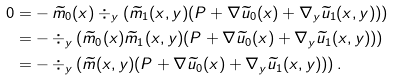Convert formula to latex. <formula><loc_0><loc_0><loc_500><loc_500>0 = & - \widetilde { m } _ { 0 } ( x ) \div _ { y } \left ( \widetilde { m } _ { 1 } ( x , y ) ( P + \nabla \widetilde { u } _ { 0 } ( x ) + \nabla _ { y } \widetilde { u } _ { 1 } ( x , y ) ) \right ) \\ = & - \div _ { y } \left ( \widetilde { m } _ { 0 } ( x ) \widetilde { m } _ { 1 } ( x , y ) ( P + \nabla \widetilde { u } _ { 0 } ( x ) + \nabla _ { y } \widetilde { u } _ { 1 } ( x , y ) ) \right ) \\ = & - \div _ { y } \left ( \widetilde { m } ( x , y ) ( P + \nabla \widetilde { u } _ { 0 } ( x ) + \nabla _ { y } \widetilde { u } _ { 1 } ( x , y ) ) \right ) .</formula> 